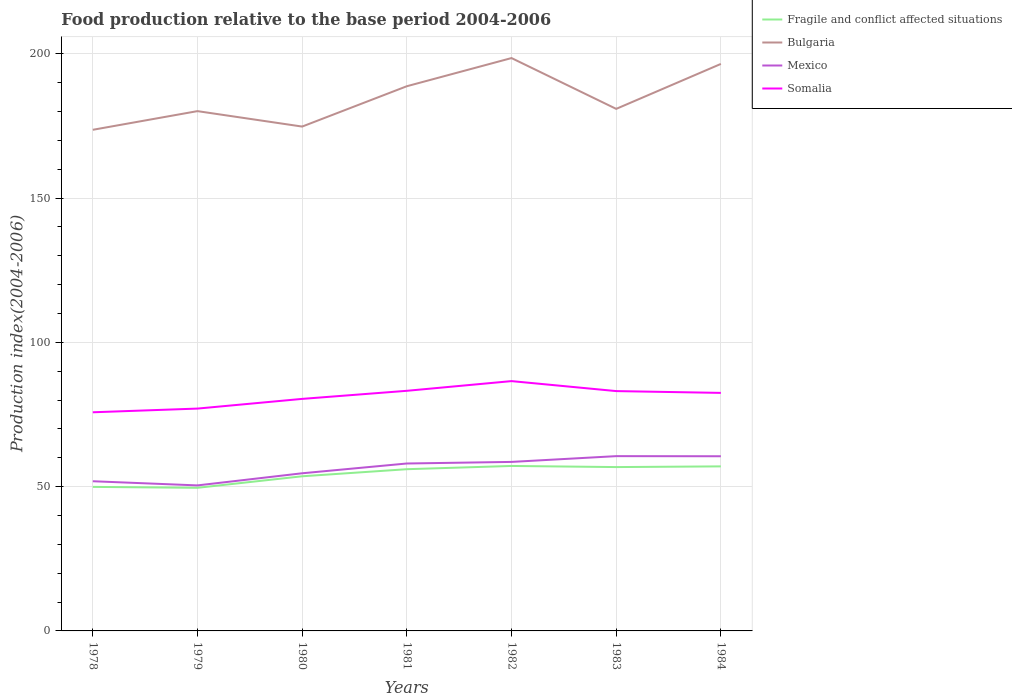Is the number of lines equal to the number of legend labels?
Keep it short and to the point. Yes. Across all years, what is the maximum food production index in Mexico?
Keep it short and to the point. 50.43. In which year was the food production index in Somalia maximum?
Your answer should be very brief. 1978. What is the total food production index in Bulgaria in the graph?
Provide a short and direct response. -15.1. What is the difference between the highest and the second highest food production index in Somalia?
Offer a very short reply. 10.8. Is the food production index in Mexico strictly greater than the food production index in Fragile and conflict affected situations over the years?
Offer a very short reply. No. How many lines are there?
Your response must be concise. 4. How many years are there in the graph?
Provide a short and direct response. 7. What is the difference between two consecutive major ticks on the Y-axis?
Your response must be concise. 50. Are the values on the major ticks of Y-axis written in scientific E-notation?
Your answer should be compact. No. Does the graph contain grids?
Provide a short and direct response. Yes. Where does the legend appear in the graph?
Make the answer very short. Top right. How are the legend labels stacked?
Offer a terse response. Vertical. What is the title of the graph?
Your response must be concise. Food production relative to the base period 2004-2006. Does "Middle East & North Africa (developing only)" appear as one of the legend labels in the graph?
Your answer should be very brief. No. What is the label or title of the Y-axis?
Keep it short and to the point. Production index(2004-2006). What is the Production index(2004-2006) in Fragile and conflict affected situations in 1978?
Your answer should be compact. 49.91. What is the Production index(2004-2006) of Bulgaria in 1978?
Offer a very short reply. 173.66. What is the Production index(2004-2006) of Mexico in 1978?
Your answer should be compact. 51.87. What is the Production index(2004-2006) of Somalia in 1978?
Keep it short and to the point. 75.77. What is the Production index(2004-2006) of Fragile and conflict affected situations in 1979?
Offer a very short reply. 49.59. What is the Production index(2004-2006) in Bulgaria in 1979?
Your response must be concise. 180.13. What is the Production index(2004-2006) in Mexico in 1979?
Offer a terse response. 50.43. What is the Production index(2004-2006) in Somalia in 1979?
Ensure brevity in your answer.  77.05. What is the Production index(2004-2006) of Fragile and conflict affected situations in 1980?
Offer a very short reply. 53.59. What is the Production index(2004-2006) in Bulgaria in 1980?
Offer a terse response. 174.78. What is the Production index(2004-2006) of Mexico in 1980?
Provide a short and direct response. 54.63. What is the Production index(2004-2006) of Somalia in 1980?
Make the answer very short. 80.41. What is the Production index(2004-2006) of Fragile and conflict affected situations in 1981?
Make the answer very short. 56.04. What is the Production index(2004-2006) of Bulgaria in 1981?
Provide a short and direct response. 188.76. What is the Production index(2004-2006) of Mexico in 1981?
Provide a short and direct response. 58.02. What is the Production index(2004-2006) of Somalia in 1981?
Offer a terse response. 83.21. What is the Production index(2004-2006) in Fragile and conflict affected situations in 1982?
Give a very brief answer. 57.17. What is the Production index(2004-2006) in Bulgaria in 1982?
Your response must be concise. 198.52. What is the Production index(2004-2006) of Mexico in 1982?
Give a very brief answer. 58.57. What is the Production index(2004-2006) in Somalia in 1982?
Offer a very short reply. 86.57. What is the Production index(2004-2006) in Fragile and conflict affected situations in 1983?
Provide a succinct answer. 56.78. What is the Production index(2004-2006) of Bulgaria in 1983?
Make the answer very short. 180.91. What is the Production index(2004-2006) of Mexico in 1983?
Offer a terse response. 60.57. What is the Production index(2004-2006) of Somalia in 1983?
Your response must be concise. 83.11. What is the Production index(2004-2006) of Fragile and conflict affected situations in 1984?
Keep it short and to the point. 57.02. What is the Production index(2004-2006) in Bulgaria in 1984?
Your response must be concise. 196.49. What is the Production index(2004-2006) of Mexico in 1984?
Offer a terse response. 60.53. What is the Production index(2004-2006) in Somalia in 1984?
Your answer should be compact. 82.49. Across all years, what is the maximum Production index(2004-2006) of Fragile and conflict affected situations?
Your response must be concise. 57.17. Across all years, what is the maximum Production index(2004-2006) in Bulgaria?
Your answer should be compact. 198.52. Across all years, what is the maximum Production index(2004-2006) in Mexico?
Your answer should be very brief. 60.57. Across all years, what is the maximum Production index(2004-2006) of Somalia?
Ensure brevity in your answer.  86.57. Across all years, what is the minimum Production index(2004-2006) of Fragile and conflict affected situations?
Keep it short and to the point. 49.59. Across all years, what is the minimum Production index(2004-2006) in Bulgaria?
Provide a succinct answer. 173.66. Across all years, what is the minimum Production index(2004-2006) in Mexico?
Offer a very short reply. 50.43. Across all years, what is the minimum Production index(2004-2006) in Somalia?
Keep it short and to the point. 75.77. What is the total Production index(2004-2006) in Fragile and conflict affected situations in the graph?
Your answer should be compact. 380.11. What is the total Production index(2004-2006) of Bulgaria in the graph?
Provide a short and direct response. 1293.25. What is the total Production index(2004-2006) in Mexico in the graph?
Give a very brief answer. 394.62. What is the total Production index(2004-2006) in Somalia in the graph?
Give a very brief answer. 568.61. What is the difference between the Production index(2004-2006) in Fragile and conflict affected situations in 1978 and that in 1979?
Ensure brevity in your answer.  0.32. What is the difference between the Production index(2004-2006) of Bulgaria in 1978 and that in 1979?
Your answer should be compact. -6.47. What is the difference between the Production index(2004-2006) of Mexico in 1978 and that in 1979?
Ensure brevity in your answer.  1.44. What is the difference between the Production index(2004-2006) in Somalia in 1978 and that in 1979?
Offer a very short reply. -1.28. What is the difference between the Production index(2004-2006) in Fragile and conflict affected situations in 1978 and that in 1980?
Your answer should be compact. -3.68. What is the difference between the Production index(2004-2006) in Bulgaria in 1978 and that in 1980?
Ensure brevity in your answer.  -1.12. What is the difference between the Production index(2004-2006) in Mexico in 1978 and that in 1980?
Offer a very short reply. -2.76. What is the difference between the Production index(2004-2006) in Somalia in 1978 and that in 1980?
Provide a succinct answer. -4.64. What is the difference between the Production index(2004-2006) of Fragile and conflict affected situations in 1978 and that in 1981?
Give a very brief answer. -6.13. What is the difference between the Production index(2004-2006) of Bulgaria in 1978 and that in 1981?
Your response must be concise. -15.1. What is the difference between the Production index(2004-2006) in Mexico in 1978 and that in 1981?
Ensure brevity in your answer.  -6.15. What is the difference between the Production index(2004-2006) in Somalia in 1978 and that in 1981?
Provide a short and direct response. -7.44. What is the difference between the Production index(2004-2006) of Fragile and conflict affected situations in 1978 and that in 1982?
Provide a short and direct response. -7.26. What is the difference between the Production index(2004-2006) of Bulgaria in 1978 and that in 1982?
Offer a very short reply. -24.86. What is the difference between the Production index(2004-2006) of Fragile and conflict affected situations in 1978 and that in 1983?
Your answer should be very brief. -6.87. What is the difference between the Production index(2004-2006) of Bulgaria in 1978 and that in 1983?
Your response must be concise. -7.25. What is the difference between the Production index(2004-2006) of Mexico in 1978 and that in 1983?
Ensure brevity in your answer.  -8.7. What is the difference between the Production index(2004-2006) of Somalia in 1978 and that in 1983?
Provide a succinct answer. -7.34. What is the difference between the Production index(2004-2006) of Fragile and conflict affected situations in 1978 and that in 1984?
Make the answer very short. -7.11. What is the difference between the Production index(2004-2006) of Bulgaria in 1978 and that in 1984?
Offer a terse response. -22.83. What is the difference between the Production index(2004-2006) of Mexico in 1978 and that in 1984?
Offer a very short reply. -8.66. What is the difference between the Production index(2004-2006) in Somalia in 1978 and that in 1984?
Keep it short and to the point. -6.72. What is the difference between the Production index(2004-2006) of Fragile and conflict affected situations in 1979 and that in 1980?
Provide a short and direct response. -3.99. What is the difference between the Production index(2004-2006) in Bulgaria in 1979 and that in 1980?
Your answer should be very brief. 5.35. What is the difference between the Production index(2004-2006) in Somalia in 1979 and that in 1980?
Your answer should be very brief. -3.36. What is the difference between the Production index(2004-2006) in Fragile and conflict affected situations in 1979 and that in 1981?
Make the answer very short. -6.45. What is the difference between the Production index(2004-2006) in Bulgaria in 1979 and that in 1981?
Your answer should be compact. -8.63. What is the difference between the Production index(2004-2006) of Mexico in 1979 and that in 1981?
Provide a succinct answer. -7.59. What is the difference between the Production index(2004-2006) of Somalia in 1979 and that in 1981?
Make the answer very short. -6.16. What is the difference between the Production index(2004-2006) in Fragile and conflict affected situations in 1979 and that in 1982?
Your answer should be very brief. -7.58. What is the difference between the Production index(2004-2006) in Bulgaria in 1979 and that in 1982?
Offer a terse response. -18.39. What is the difference between the Production index(2004-2006) of Mexico in 1979 and that in 1982?
Keep it short and to the point. -8.14. What is the difference between the Production index(2004-2006) of Somalia in 1979 and that in 1982?
Provide a succinct answer. -9.52. What is the difference between the Production index(2004-2006) in Fragile and conflict affected situations in 1979 and that in 1983?
Your answer should be compact. -7.18. What is the difference between the Production index(2004-2006) of Bulgaria in 1979 and that in 1983?
Your answer should be compact. -0.78. What is the difference between the Production index(2004-2006) of Mexico in 1979 and that in 1983?
Keep it short and to the point. -10.14. What is the difference between the Production index(2004-2006) of Somalia in 1979 and that in 1983?
Your answer should be compact. -6.06. What is the difference between the Production index(2004-2006) in Fragile and conflict affected situations in 1979 and that in 1984?
Your response must be concise. -7.43. What is the difference between the Production index(2004-2006) in Bulgaria in 1979 and that in 1984?
Your answer should be very brief. -16.36. What is the difference between the Production index(2004-2006) of Mexico in 1979 and that in 1984?
Ensure brevity in your answer.  -10.1. What is the difference between the Production index(2004-2006) in Somalia in 1979 and that in 1984?
Your response must be concise. -5.44. What is the difference between the Production index(2004-2006) of Fragile and conflict affected situations in 1980 and that in 1981?
Offer a very short reply. -2.45. What is the difference between the Production index(2004-2006) in Bulgaria in 1980 and that in 1981?
Make the answer very short. -13.98. What is the difference between the Production index(2004-2006) of Mexico in 1980 and that in 1981?
Offer a very short reply. -3.39. What is the difference between the Production index(2004-2006) in Somalia in 1980 and that in 1981?
Offer a very short reply. -2.8. What is the difference between the Production index(2004-2006) of Fragile and conflict affected situations in 1980 and that in 1982?
Your answer should be very brief. -3.58. What is the difference between the Production index(2004-2006) of Bulgaria in 1980 and that in 1982?
Offer a very short reply. -23.74. What is the difference between the Production index(2004-2006) in Mexico in 1980 and that in 1982?
Ensure brevity in your answer.  -3.94. What is the difference between the Production index(2004-2006) of Somalia in 1980 and that in 1982?
Offer a terse response. -6.16. What is the difference between the Production index(2004-2006) of Fragile and conflict affected situations in 1980 and that in 1983?
Your answer should be very brief. -3.19. What is the difference between the Production index(2004-2006) of Bulgaria in 1980 and that in 1983?
Your response must be concise. -6.13. What is the difference between the Production index(2004-2006) in Mexico in 1980 and that in 1983?
Your answer should be very brief. -5.94. What is the difference between the Production index(2004-2006) of Fragile and conflict affected situations in 1980 and that in 1984?
Offer a terse response. -3.43. What is the difference between the Production index(2004-2006) of Bulgaria in 1980 and that in 1984?
Make the answer very short. -21.71. What is the difference between the Production index(2004-2006) in Somalia in 1980 and that in 1984?
Keep it short and to the point. -2.08. What is the difference between the Production index(2004-2006) of Fragile and conflict affected situations in 1981 and that in 1982?
Your answer should be compact. -1.13. What is the difference between the Production index(2004-2006) in Bulgaria in 1981 and that in 1982?
Provide a short and direct response. -9.76. What is the difference between the Production index(2004-2006) in Mexico in 1981 and that in 1982?
Ensure brevity in your answer.  -0.55. What is the difference between the Production index(2004-2006) in Somalia in 1981 and that in 1982?
Ensure brevity in your answer.  -3.36. What is the difference between the Production index(2004-2006) of Fragile and conflict affected situations in 1981 and that in 1983?
Keep it short and to the point. -0.74. What is the difference between the Production index(2004-2006) in Bulgaria in 1981 and that in 1983?
Provide a succinct answer. 7.85. What is the difference between the Production index(2004-2006) in Mexico in 1981 and that in 1983?
Provide a short and direct response. -2.55. What is the difference between the Production index(2004-2006) in Fragile and conflict affected situations in 1981 and that in 1984?
Offer a very short reply. -0.98. What is the difference between the Production index(2004-2006) of Bulgaria in 1981 and that in 1984?
Your answer should be compact. -7.73. What is the difference between the Production index(2004-2006) in Mexico in 1981 and that in 1984?
Your response must be concise. -2.51. What is the difference between the Production index(2004-2006) in Somalia in 1981 and that in 1984?
Provide a succinct answer. 0.72. What is the difference between the Production index(2004-2006) in Fragile and conflict affected situations in 1982 and that in 1983?
Make the answer very short. 0.39. What is the difference between the Production index(2004-2006) of Bulgaria in 1982 and that in 1983?
Your response must be concise. 17.61. What is the difference between the Production index(2004-2006) of Mexico in 1982 and that in 1983?
Give a very brief answer. -2. What is the difference between the Production index(2004-2006) in Somalia in 1982 and that in 1983?
Provide a short and direct response. 3.46. What is the difference between the Production index(2004-2006) in Fragile and conflict affected situations in 1982 and that in 1984?
Provide a short and direct response. 0.15. What is the difference between the Production index(2004-2006) of Bulgaria in 1982 and that in 1984?
Your answer should be very brief. 2.03. What is the difference between the Production index(2004-2006) in Mexico in 1982 and that in 1984?
Give a very brief answer. -1.96. What is the difference between the Production index(2004-2006) in Somalia in 1982 and that in 1984?
Ensure brevity in your answer.  4.08. What is the difference between the Production index(2004-2006) of Fragile and conflict affected situations in 1983 and that in 1984?
Provide a succinct answer. -0.24. What is the difference between the Production index(2004-2006) in Bulgaria in 1983 and that in 1984?
Offer a terse response. -15.58. What is the difference between the Production index(2004-2006) of Somalia in 1983 and that in 1984?
Your response must be concise. 0.62. What is the difference between the Production index(2004-2006) in Fragile and conflict affected situations in 1978 and the Production index(2004-2006) in Bulgaria in 1979?
Your answer should be compact. -130.22. What is the difference between the Production index(2004-2006) in Fragile and conflict affected situations in 1978 and the Production index(2004-2006) in Mexico in 1979?
Provide a short and direct response. -0.52. What is the difference between the Production index(2004-2006) in Fragile and conflict affected situations in 1978 and the Production index(2004-2006) in Somalia in 1979?
Ensure brevity in your answer.  -27.14. What is the difference between the Production index(2004-2006) in Bulgaria in 1978 and the Production index(2004-2006) in Mexico in 1979?
Ensure brevity in your answer.  123.23. What is the difference between the Production index(2004-2006) of Bulgaria in 1978 and the Production index(2004-2006) of Somalia in 1979?
Make the answer very short. 96.61. What is the difference between the Production index(2004-2006) of Mexico in 1978 and the Production index(2004-2006) of Somalia in 1979?
Provide a succinct answer. -25.18. What is the difference between the Production index(2004-2006) in Fragile and conflict affected situations in 1978 and the Production index(2004-2006) in Bulgaria in 1980?
Ensure brevity in your answer.  -124.87. What is the difference between the Production index(2004-2006) of Fragile and conflict affected situations in 1978 and the Production index(2004-2006) of Mexico in 1980?
Ensure brevity in your answer.  -4.72. What is the difference between the Production index(2004-2006) in Fragile and conflict affected situations in 1978 and the Production index(2004-2006) in Somalia in 1980?
Ensure brevity in your answer.  -30.5. What is the difference between the Production index(2004-2006) in Bulgaria in 1978 and the Production index(2004-2006) in Mexico in 1980?
Give a very brief answer. 119.03. What is the difference between the Production index(2004-2006) in Bulgaria in 1978 and the Production index(2004-2006) in Somalia in 1980?
Provide a short and direct response. 93.25. What is the difference between the Production index(2004-2006) of Mexico in 1978 and the Production index(2004-2006) of Somalia in 1980?
Your response must be concise. -28.54. What is the difference between the Production index(2004-2006) of Fragile and conflict affected situations in 1978 and the Production index(2004-2006) of Bulgaria in 1981?
Your answer should be very brief. -138.85. What is the difference between the Production index(2004-2006) of Fragile and conflict affected situations in 1978 and the Production index(2004-2006) of Mexico in 1981?
Offer a terse response. -8.11. What is the difference between the Production index(2004-2006) in Fragile and conflict affected situations in 1978 and the Production index(2004-2006) in Somalia in 1981?
Keep it short and to the point. -33.3. What is the difference between the Production index(2004-2006) in Bulgaria in 1978 and the Production index(2004-2006) in Mexico in 1981?
Provide a succinct answer. 115.64. What is the difference between the Production index(2004-2006) of Bulgaria in 1978 and the Production index(2004-2006) of Somalia in 1981?
Your answer should be compact. 90.45. What is the difference between the Production index(2004-2006) in Mexico in 1978 and the Production index(2004-2006) in Somalia in 1981?
Your response must be concise. -31.34. What is the difference between the Production index(2004-2006) of Fragile and conflict affected situations in 1978 and the Production index(2004-2006) of Bulgaria in 1982?
Provide a short and direct response. -148.61. What is the difference between the Production index(2004-2006) of Fragile and conflict affected situations in 1978 and the Production index(2004-2006) of Mexico in 1982?
Provide a short and direct response. -8.66. What is the difference between the Production index(2004-2006) of Fragile and conflict affected situations in 1978 and the Production index(2004-2006) of Somalia in 1982?
Your answer should be very brief. -36.66. What is the difference between the Production index(2004-2006) of Bulgaria in 1978 and the Production index(2004-2006) of Mexico in 1982?
Keep it short and to the point. 115.09. What is the difference between the Production index(2004-2006) of Bulgaria in 1978 and the Production index(2004-2006) of Somalia in 1982?
Provide a short and direct response. 87.09. What is the difference between the Production index(2004-2006) in Mexico in 1978 and the Production index(2004-2006) in Somalia in 1982?
Offer a terse response. -34.7. What is the difference between the Production index(2004-2006) in Fragile and conflict affected situations in 1978 and the Production index(2004-2006) in Bulgaria in 1983?
Give a very brief answer. -131. What is the difference between the Production index(2004-2006) in Fragile and conflict affected situations in 1978 and the Production index(2004-2006) in Mexico in 1983?
Your answer should be compact. -10.66. What is the difference between the Production index(2004-2006) in Fragile and conflict affected situations in 1978 and the Production index(2004-2006) in Somalia in 1983?
Provide a succinct answer. -33.2. What is the difference between the Production index(2004-2006) of Bulgaria in 1978 and the Production index(2004-2006) of Mexico in 1983?
Ensure brevity in your answer.  113.09. What is the difference between the Production index(2004-2006) of Bulgaria in 1978 and the Production index(2004-2006) of Somalia in 1983?
Offer a terse response. 90.55. What is the difference between the Production index(2004-2006) of Mexico in 1978 and the Production index(2004-2006) of Somalia in 1983?
Keep it short and to the point. -31.24. What is the difference between the Production index(2004-2006) in Fragile and conflict affected situations in 1978 and the Production index(2004-2006) in Bulgaria in 1984?
Offer a very short reply. -146.58. What is the difference between the Production index(2004-2006) of Fragile and conflict affected situations in 1978 and the Production index(2004-2006) of Mexico in 1984?
Your answer should be compact. -10.62. What is the difference between the Production index(2004-2006) in Fragile and conflict affected situations in 1978 and the Production index(2004-2006) in Somalia in 1984?
Your answer should be very brief. -32.58. What is the difference between the Production index(2004-2006) in Bulgaria in 1978 and the Production index(2004-2006) in Mexico in 1984?
Ensure brevity in your answer.  113.13. What is the difference between the Production index(2004-2006) in Bulgaria in 1978 and the Production index(2004-2006) in Somalia in 1984?
Keep it short and to the point. 91.17. What is the difference between the Production index(2004-2006) of Mexico in 1978 and the Production index(2004-2006) of Somalia in 1984?
Make the answer very short. -30.62. What is the difference between the Production index(2004-2006) in Fragile and conflict affected situations in 1979 and the Production index(2004-2006) in Bulgaria in 1980?
Give a very brief answer. -125.19. What is the difference between the Production index(2004-2006) of Fragile and conflict affected situations in 1979 and the Production index(2004-2006) of Mexico in 1980?
Your answer should be compact. -5.04. What is the difference between the Production index(2004-2006) in Fragile and conflict affected situations in 1979 and the Production index(2004-2006) in Somalia in 1980?
Offer a terse response. -30.82. What is the difference between the Production index(2004-2006) of Bulgaria in 1979 and the Production index(2004-2006) of Mexico in 1980?
Your answer should be compact. 125.5. What is the difference between the Production index(2004-2006) of Bulgaria in 1979 and the Production index(2004-2006) of Somalia in 1980?
Your answer should be compact. 99.72. What is the difference between the Production index(2004-2006) of Mexico in 1979 and the Production index(2004-2006) of Somalia in 1980?
Offer a terse response. -29.98. What is the difference between the Production index(2004-2006) in Fragile and conflict affected situations in 1979 and the Production index(2004-2006) in Bulgaria in 1981?
Provide a succinct answer. -139.17. What is the difference between the Production index(2004-2006) in Fragile and conflict affected situations in 1979 and the Production index(2004-2006) in Mexico in 1981?
Your answer should be very brief. -8.43. What is the difference between the Production index(2004-2006) in Fragile and conflict affected situations in 1979 and the Production index(2004-2006) in Somalia in 1981?
Keep it short and to the point. -33.62. What is the difference between the Production index(2004-2006) in Bulgaria in 1979 and the Production index(2004-2006) in Mexico in 1981?
Make the answer very short. 122.11. What is the difference between the Production index(2004-2006) in Bulgaria in 1979 and the Production index(2004-2006) in Somalia in 1981?
Ensure brevity in your answer.  96.92. What is the difference between the Production index(2004-2006) in Mexico in 1979 and the Production index(2004-2006) in Somalia in 1981?
Your answer should be compact. -32.78. What is the difference between the Production index(2004-2006) of Fragile and conflict affected situations in 1979 and the Production index(2004-2006) of Bulgaria in 1982?
Your answer should be very brief. -148.93. What is the difference between the Production index(2004-2006) in Fragile and conflict affected situations in 1979 and the Production index(2004-2006) in Mexico in 1982?
Your answer should be very brief. -8.98. What is the difference between the Production index(2004-2006) in Fragile and conflict affected situations in 1979 and the Production index(2004-2006) in Somalia in 1982?
Provide a short and direct response. -36.98. What is the difference between the Production index(2004-2006) of Bulgaria in 1979 and the Production index(2004-2006) of Mexico in 1982?
Provide a short and direct response. 121.56. What is the difference between the Production index(2004-2006) in Bulgaria in 1979 and the Production index(2004-2006) in Somalia in 1982?
Provide a succinct answer. 93.56. What is the difference between the Production index(2004-2006) of Mexico in 1979 and the Production index(2004-2006) of Somalia in 1982?
Your answer should be compact. -36.14. What is the difference between the Production index(2004-2006) of Fragile and conflict affected situations in 1979 and the Production index(2004-2006) of Bulgaria in 1983?
Offer a very short reply. -131.32. What is the difference between the Production index(2004-2006) of Fragile and conflict affected situations in 1979 and the Production index(2004-2006) of Mexico in 1983?
Your answer should be compact. -10.98. What is the difference between the Production index(2004-2006) in Fragile and conflict affected situations in 1979 and the Production index(2004-2006) in Somalia in 1983?
Your answer should be compact. -33.52. What is the difference between the Production index(2004-2006) in Bulgaria in 1979 and the Production index(2004-2006) in Mexico in 1983?
Keep it short and to the point. 119.56. What is the difference between the Production index(2004-2006) in Bulgaria in 1979 and the Production index(2004-2006) in Somalia in 1983?
Make the answer very short. 97.02. What is the difference between the Production index(2004-2006) in Mexico in 1979 and the Production index(2004-2006) in Somalia in 1983?
Your answer should be very brief. -32.68. What is the difference between the Production index(2004-2006) of Fragile and conflict affected situations in 1979 and the Production index(2004-2006) of Bulgaria in 1984?
Your answer should be very brief. -146.9. What is the difference between the Production index(2004-2006) of Fragile and conflict affected situations in 1979 and the Production index(2004-2006) of Mexico in 1984?
Give a very brief answer. -10.94. What is the difference between the Production index(2004-2006) in Fragile and conflict affected situations in 1979 and the Production index(2004-2006) in Somalia in 1984?
Your response must be concise. -32.9. What is the difference between the Production index(2004-2006) of Bulgaria in 1979 and the Production index(2004-2006) of Mexico in 1984?
Your answer should be compact. 119.6. What is the difference between the Production index(2004-2006) in Bulgaria in 1979 and the Production index(2004-2006) in Somalia in 1984?
Your answer should be compact. 97.64. What is the difference between the Production index(2004-2006) of Mexico in 1979 and the Production index(2004-2006) of Somalia in 1984?
Provide a succinct answer. -32.06. What is the difference between the Production index(2004-2006) in Fragile and conflict affected situations in 1980 and the Production index(2004-2006) in Bulgaria in 1981?
Your answer should be very brief. -135.17. What is the difference between the Production index(2004-2006) of Fragile and conflict affected situations in 1980 and the Production index(2004-2006) of Mexico in 1981?
Provide a short and direct response. -4.43. What is the difference between the Production index(2004-2006) of Fragile and conflict affected situations in 1980 and the Production index(2004-2006) of Somalia in 1981?
Your answer should be compact. -29.62. What is the difference between the Production index(2004-2006) in Bulgaria in 1980 and the Production index(2004-2006) in Mexico in 1981?
Make the answer very short. 116.76. What is the difference between the Production index(2004-2006) of Bulgaria in 1980 and the Production index(2004-2006) of Somalia in 1981?
Ensure brevity in your answer.  91.57. What is the difference between the Production index(2004-2006) in Mexico in 1980 and the Production index(2004-2006) in Somalia in 1981?
Make the answer very short. -28.58. What is the difference between the Production index(2004-2006) of Fragile and conflict affected situations in 1980 and the Production index(2004-2006) of Bulgaria in 1982?
Provide a succinct answer. -144.93. What is the difference between the Production index(2004-2006) of Fragile and conflict affected situations in 1980 and the Production index(2004-2006) of Mexico in 1982?
Your response must be concise. -4.98. What is the difference between the Production index(2004-2006) of Fragile and conflict affected situations in 1980 and the Production index(2004-2006) of Somalia in 1982?
Give a very brief answer. -32.98. What is the difference between the Production index(2004-2006) in Bulgaria in 1980 and the Production index(2004-2006) in Mexico in 1982?
Your answer should be compact. 116.21. What is the difference between the Production index(2004-2006) in Bulgaria in 1980 and the Production index(2004-2006) in Somalia in 1982?
Provide a succinct answer. 88.21. What is the difference between the Production index(2004-2006) in Mexico in 1980 and the Production index(2004-2006) in Somalia in 1982?
Your response must be concise. -31.94. What is the difference between the Production index(2004-2006) in Fragile and conflict affected situations in 1980 and the Production index(2004-2006) in Bulgaria in 1983?
Provide a succinct answer. -127.32. What is the difference between the Production index(2004-2006) of Fragile and conflict affected situations in 1980 and the Production index(2004-2006) of Mexico in 1983?
Offer a very short reply. -6.98. What is the difference between the Production index(2004-2006) in Fragile and conflict affected situations in 1980 and the Production index(2004-2006) in Somalia in 1983?
Your answer should be compact. -29.52. What is the difference between the Production index(2004-2006) in Bulgaria in 1980 and the Production index(2004-2006) in Mexico in 1983?
Your answer should be compact. 114.21. What is the difference between the Production index(2004-2006) of Bulgaria in 1980 and the Production index(2004-2006) of Somalia in 1983?
Your answer should be compact. 91.67. What is the difference between the Production index(2004-2006) of Mexico in 1980 and the Production index(2004-2006) of Somalia in 1983?
Make the answer very short. -28.48. What is the difference between the Production index(2004-2006) of Fragile and conflict affected situations in 1980 and the Production index(2004-2006) of Bulgaria in 1984?
Provide a succinct answer. -142.9. What is the difference between the Production index(2004-2006) of Fragile and conflict affected situations in 1980 and the Production index(2004-2006) of Mexico in 1984?
Offer a very short reply. -6.94. What is the difference between the Production index(2004-2006) in Fragile and conflict affected situations in 1980 and the Production index(2004-2006) in Somalia in 1984?
Offer a very short reply. -28.9. What is the difference between the Production index(2004-2006) in Bulgaria in 1980 and the Production index(2004-2006) in Mexico in 1984?
Offer a very short reply. 114.25. What is the difference between the Production index(2004-2006) of Bulgaria in 1980 and the Production index(2004-2006) of Somalia in 1984?
Keep it short and to the point. 92.29. What is the difference between the Production index(2004-2006) in Mexico in 1980 and the Production index(2004-2006) in Somalia in 1984?
Provide a short and direct response. -27.86. What is the difference between the Production index(2004-2006) in Fragile and conflict affected situations in 1981 and the Production index(2004-2006) in Bulgaria in 1982?
Give a very brief answer. -142.48. What is the difference between the Production index(2004-2006) in Fragile and conflict affected situations in 1981 and the Production index(2004-2006) in Mexico in 1982?
Provide a succinct answer. -2.53. What is the difference between the Production index(2004-2006) of Fragile and conflict affected situations in 1981 and the Production index(2004-2006) of Somalia in 1982?
Your answer should be compact. -30.53. What is the difference between the Production index(2004-2006) in Bulgaria in 1981 and the Production index(2004-2006) in Mexico in 1982?
Make the answer very short. 130.19. What is the difference between the Production index(2004-2006) of Bulgaria in 1981 and the Production index(2004-2006) of Somalia in 1982?
Your answer should be very brief. 102.19. What is the difference between the Production index(2004-2006) in Mexico in 1981 and the Production index(2004-2006) in Somalia in 1982?
Ensure brevity in your answer.  -28.55. What is the difference between the Production index(2004-2006) of Fragile and conflict affected situations in 1981 and the Production index(2004-2006) of Bulgaria in 1983?
Give a very brief answer. -124.87. What is the difference between the Production index(2004-2006) in Fragile and conflict affected situations in 1981 and the Production index(2004-2006) in Mexico in 1983?
Provide a succinct answer. -4.53. What is the difference between the Production index(2004-2006) of Fragile and conflict affected situations in 1981 and the Production index(2004-2006) of Somalia in 1983?
Keep it short and to the point. -27.07. What is the difference between the Production index(2004-2006) of Bulgaria in 1981 and the Production index(2004-2006) of Mexico in 1983?
Offer a very short reply. 128.19. What is the difference between the Production index(2004-2006) in Bulgaria in 1981 and the Production index(2004-2006) in Somalia in 1983?
Keep it short and to the point. 105.65. What is the difference between the Production index(2004-2006) in Mexico in 1981 and the Production index(2004-2006) in Somalia in 1983?
Ensure brevity in your answer.  -25.09. What is the difference between the Production index(2004-2006) of Fragile and conflict affected situations in 1981 and the Production index(2004-2006) of Bulgaria in 1984?
Give a very brief answer. -140.45. What is the difference between the Production index(2004-2006) of Fragile and conflict affected situations in 1981 and the Production index(2004-2006) of Mexico in 1984?
Your answer should be compact. -4.49. What is the difference between the Production index(2004-2006) in Fragile and conflict affected situations in 1981 and the Production index(2004-2006) in Somalia in 1984?
Keep it short and to the point. -26.45. What is the difference between the Production index(2004-2006) of Bulgaria in 1981 and the Production index(2004-2006) of Mexico in 1984?
Offer a terse response. 128.23. What is the difference between the Production index(2004-2006) in Bulgaria in 1981 and the Production index(2004-2006) in Somalia in 1984?
Offer a very short reply. 106.27. What is the difference between the Production index(2004-2006) in Mexico in 1981 and the Production index(2004-2006) in Somalia in 1984?
Make the answer very short. -24.47. What is the difference between the Production index(2004-2006) in Fragile and conflict affected situations in 1982 and the Production index(2004-2006) in Bulgaria in 1983?
Make the answer very short. -123.74. What is the difference between the Production index(2004-2006) of Fragile and conflict affected situations in 1982 and the Production index(2004-2006) of Mexico in 1983?
Keep it short and to the point. -3.4. What is the difference between the Production index(2004-2006) of Fragile and conflict affected situations in 1982 and the Production index(2004-2006) of Somalia in 1983?
Your response must be concise. -25.94. What is the difference between the Production index(2004-2006) in Bulgaria in 1982 and the Production index(2004-2006) in Mexico in 1983?
Offer a very short reply. 137.95. What is the difference between the Production index(2004-2006) of Bulgaria in 1982 and the Production index(2004-2006) of Somalia in 1983?
Give a very brief answer. 115.41. What is the difference between the Production index(2004-2006) of Mexico in 1982 and the Production index(2004-2006) of Somalia in 1983?
Ensure brevity in your answer.  -24.54. What is the difference between the Production index(2004-2006) in Fragile and conflict affected situations in 1982 and the Production index(2004-2006) in Bulgaria in 1984?
Your answer should be compact. -139.32. What is the difference between the Production index(2004-2006) in Fragile and conflict affected situations in 1982 and the Production index(2004-2006) in Mexico in 1984?
Your answer should be very brief. -3.36. What is the difference between the Production index(2004-2006) in Fragile and conflict affected situations in 1982 and the Production index(2004-2006) in Somalia in 1984?
Make the answer very short. -25.32. What is the difference between the Production index(2004-2006) in Bulgaria in 1982 and the Production index(2004-2006) in Mexico in 1984?
Your answer should be very brief. 137.99. What is the difference between the Production index(2004-2006) of Bulgaria in 1982 and the Production index(2004-2006) of Somalia in 1984?
Keep it short and to the point. 116.03. What is the difference between the Production index(2004-2006) of Mexico in 1982 and the Production index(2004-2006) of Somalia in 1984?
Make the answer very short. -23.92. What is the difference between the Production index(2004-2006) of Fragile and conflict affected situations in 1983 and the Production index(2004-2006) of Bulgaria in 1984?
Your answer should be compact. -139.71. What is the difference between the Production index(2004-2006) in Fragile and conflict affected situations in 1983 and the Production index(2004-2006) in Mexico in 1984?
Make the answer very short. -3.75. What is the difference between the Production index(2004-2006) in Fragile and conflict affected situations in 1983 and the Production index(2004-2006) in Somalia in 1984?
Your answer should be very brief. -25.71. What is the difference between the Production index(2004-2006) of Bulgaria in 1983 and the Production index(2004-2006) of Mexico in 1984?
Provide a short and direct response. 120.38. What is the difference between the Production index(2004-2006) in Bulgaria in 1983 and the Production index(2004-2006) in Somalia in 1984?
Keep it short and to the point. 98.42. What is the difference between the Production index(2004-2006) in Mexico in 1983 and the Production index(2004-2006) in Somalia in 1984?
Offer a terse response. -21.92. What is the average Production index(2004-2006) in Fragile and conflict affected situations per year?
Make the answer very short. 54.3. What is the average Production index(2004-2006) in Bulgaria per year?
Your response must be concise. 184.75. What is the average Production index(2004-2006) of Mexico per year?
Give a very brief answer. 56.37. What is the average Production index(2004-2006) of Somalia per year?
Offer a very short reply. 81.23. In the year 1978, what is the difference between the Production index(2004-2006) of Fragile and conflict affected situations and Production index(2004-2006) of Bulgaria?
Ensure brevity in your answer.  -123.75. In the year 1978, what is the difference between the Production index(2004-2006) of Fragile and conflict affected situations and Production index(2004-2006) of Mexico?
Keep it short and to the point. -1.96. In the year 1978, what is the difference between the Production index(2004-2006) in Fragile and conflict affected situations and Production index(2004-2006) in Somalia?
Your response must be concise. -25.86. In the year 1978, what is the difference between the Production index(2004-2006) of Bulgaria and Production index(2004-2006) of Mexico?
Ensure brevity in your answer.  121.79. In the year 1978, what is the difference between the Production index(2004-2006) of Bulgaria and Production index(2004-2006) of Somalia?
Your answer should be very brief. 97.89. In the year 1978, what is the difference between the Production index(2004-2006) in Mexico and Production index(2004-2006) in Somalia?
Provide a succinct answer. -23.9. In the year 1979, what is the difference between the Production index(2004-2006) in Fragile and conflict affected situations and Production index(2004-2006) in Bulgaria?
Ensure brevity in your answer.  -130.54. In the year 1979, what is the difference between the Production index(2004-2006) in Fragile and conflict affected situations and Production index(2004-2006) in Mexico?
Make the answer very short. -0.84. In the year 1979, what is the difference between the Production index(2004-2006) of Fragile and conflict affected situations and Production index(2004-2006) of Somalia?
Offer a very short reply. -27.46. In the year 1979, what is the difference between the Production index(2004-2006) in Bulgaria and Production index(2004-2006) in Mexico?
Your response must be concise. 129.7. In the year 1979, what is the difference between the Production index(2004-2006) of Bulgaria and Production index(2004-2006) of Somalia?
Your answer should be compact. 103.08. In the year 1979, what is the difference between the Production index(2004-2006) in Mexico and Production index(2004-2006) in Somalia?
Make the answer very short. -26.62. In the year 1980, what is the difference between the Production index(2004-2006) of Fragile and conflict affected situations and Production index(2004-2006) of Bulgaria?
Ensure brevity in your answer.  -121.19. In the year 1980, what is the difference between the Production index(2004-2006) of Fragile and conflict affected situations and Production index(2004-2006) of Mexico?
Offer a very short reply. -1.04. In the year 1980, what is the difference between the Production index(2004-2006) of Fragile and conflict affected situations and Production index(2004-2006) of Somalia?
Your response must be concise. -26.82. In the year 1980, what is the difference between the Production index(2004-2006) of Bulgaria and Production index(2004-2006) of Mexico?
Offer a very short reply. 120.15. In the year 1980, what is the difference between the Production index(2004-2006) of Bulgaria and Production index(2004-2006) of Somalia?
Your response must be concise. 94.37. In the year 1980, what is the difference between the Production index(2004-2006) of Mexico and Production index(2004-2006) of Somalia?
Give a very brief answer. -25.78. In the year 1981, what is the difference between the Production index(2004-2006) of Fragile and conflict affected situations and Production index(2004-2006) of Bulgaria?
Offer a very short reply. -132.72. In the year 1981, what is the difference between the Production index(2004-2006) of Fragile and conflict affected situations and Production index(2004-2006) of Mexico?
Give a very brief answer. -1.98. In the year 1981, what is the difference between the Production index(2004-2006) of Fragile and conflict affected situations and Production index(2004-2006) of Somalia?
Give a very brief answer. -27.17. In the year 1981, what is the difference between the Production index(2004-2006) of Bulgaria and Production index(2004-2006) of Mexico?
Offer a terse response. 130.74. In the year 1981, what is the difference between the Production index(2004-2006) in Bulgaria and Production index(2004-2006) in Somalia?
Offer a terse response. 105.55. In the year 1981, what is the difference between the Production index(2004-2006) in Mexico and Production index(2004-2006) in Somalia?
Provide a short and direct response. -25.19. In the year 1982, what is the difference between the Production index(2004-2006) in Fragile and conflict affected situations and Production index(2004-2006) in Bulgaria?
Offer a terse response. -141.35. In the year 1982, what is the difference between the Production index(2004-2006) of Fragile and conflict affected situations and Production index(2004-2006) of Mexico?
Offer a very short reply. -1.4. In the year 1982, what is the difference between the Production index(2004-2006) in Fragile and conflict affected situations and Production index(2004-2006) in Somalia?
Offer a terse response. -29.4. In the year 1982, what is the difference between the Production index(2004-2006) of Bulgaria and Production index(2004-2006) of Mexico?
Your answer should be very brief. 139.95. In the year 1982, what is the difference between the Production index(2004-2006) in Bulgaria and Production index(2004-2006) in Somalia?
Offer a very short reply. 111.95. In the year 1982, what is the difference between the Production index(2004-2006) of Mexico and Production index(2004-2006) of Somalia?
Provide a short and direct response. -28. In the year 1983, what is the difference between the Production index(2004-2006) in Fragile and conflict affected situations and Production index(2004-2006) in Bulgaria?
Offer a very short reply. -124.13. In the year 1983, what is the difference between the Production index(2004-2006) of Fragile and conflict affected situations and Production index(2004-2006) of Mexico?
Keep it short and to the point. -3.79. In the year 1983, what is the difference between the Production index(2004-2006) of Fragile and conflict affected situations and Production index(2004-2006) of Somalia?
Provide a short and direct response. -26.33. In the year 1983, what is the difference between the Production index(2004-2006) in Bulgaria and Production index(2004-2006) in Mexico?
Offer a very short reply. 120.34. In the year 1983, what is the difference between the Production index(2004-2006) of Bulgaria and Production index(2004-2006) of Somalia?
Provide a short and direct response. 97.8. In the year 1983, what is the difference between the Production index(2004-2006) in Mexico and Production index(2004-2006) in Somalia?
Make the answer very short. -22.54. In the year 1984, what is the difference between the Production index(2004-2006) of Fragile and conflict affected situations and Production index(2004-2006) of Bulgaria?
Your answer should be compact. -139.47. In the year 1984, what is the difference between the Production index(2004-2006) of Fragile and conflict affected situations and Production index(2004-2006) of Mexico?
Provide a succinct answer. -3.51. In the year 1984, what is the difference between the Production index(2004-2006) in Fragile and conflict affected situations and Production index(2004-2006) in Somalia?
Ensure brevity in your answer.  -25.47. In the year 1984, what is the difference between the Production index(2004-2006) in Bulgaria and Production index(2004-2006) in Mexico?
Your answer should be compact. 135.96. In the year 1984, what is the difference between the Production index(2004-2006) of Bulgaria and Production index(2004-2006) of Somalia?
Your answer should be very brief. 114. In the year 1984, what is the difference between the Production index(2004-2006) of Mexico and Production index(2004-2006) of Somalia?
Your response must be concise. -21.96. What is the ratio of the Production index(2004-2006) of Fragile and conflict affected situations in 1978 to that in 1979?
Keep it short and to the point. 1.01. What is the ratio of the Production index(2004-2006) in Bulgaria in 1978 to that in 1979?
Your answer should be compact. 0.96. What is the ratio of the Production index(2004-2006) in Mexico in 1978 to that in 1979?
Offer a terse response. 1.03. What is the ratio of the Production index(2004-2006) in Somalia in 1978 to that in 1979?
Ensure brevity in your answer.  0.98. What is the ratio of the Production index(2004-2006) in Fragile and conflict affected situations in 1978 to that in 1980?
Provide a short and direct response. 0.93. What is the ratio of the Production index(2004-2006) of Mexico in 1978 to that in 1980?
Offer a terse response. 0.95. What is the ratio of the Production index(2004-2006) of Somalia in 1978 to that in 1980?
Give a very brief answer. 0.94. What is the ratio of the Production index(2004-2006) in Fragile and conflict affected situations in 1978 to that in 1981?
Offer a terse response. 0.89. What is the ratio of the Production index(2004-2006) in Mexico in 1978 to that in 1981?
Provide a short and direct response. 0.89. What is the ratio of the Production index(2004-2006) of Somalia in 1978 to that in 1981?
Your response must be concise. 0.91. What is the ratio of the Production index(2004-2006) of Fragile and conflict affected situations in 1978 to that in 1982?
Provide a succinct answer. 0.87. What is the ratio of the Production index(2004-2006) of Bulgaria in 1978 to that in 1982?
Provide a short and direct response. 0.87. What is the ratio of the Production index(2004-2006) of Mexico in 1978 to that in 1982?
Give a very brief answer. 0.89. What is the ratio of the Production index(2004-2006) in Somalia in 1978 to that in 1982?
Provide a short and direct response. 0.88. What is the ratio of the Production index(2004-2006) of Fragile and conflict affected situations in 1978 to that in 1983?
Offer a very short reply. 0.88. What is the ratio of the Production index(2004-2006) in Bulgaria in 1978 to that in 1983?
Give a very brief answer. 0.96. What is the ratio of the Production index(2004-2006) of Mexico in 1978 to that in 1983?
Offer a very short reply. 0.86. What is the ratio of the Production index(2004-2006) in Somalia in 1978 to that in 1983?
Provide a short and direct response. 0.91. What is the ratio of the Production index(2004-2006) in Fragile and conflict affected situations in 1978 to that in 1984?
Keep it short and to the point. 0.88. What is the ratio of the Production index(2004-2006) of Bulgaria in 1978 to that in 1984?
Offer a very short reply. 0.88. What is the ratio of the Production index(2004-2006) in Mexico in 1978 to that in 1984?
Your response must be concise. 0.86. What is the ratio of the Production index(2004-2006) of Somalia in 1978 to that in 1984?
Make the answer very short. 0.92. What is the ratio of the Production index(2004-2006) in Fragile and conflict affected situations in 1979 to that in 1980?
Keep it short and to the point. 0.93. What is the ratio of the Production index(2004-2006) in Bulgaria in 1979 to that in 1980?
Provide a short and direct response. 1.03. What is the ratio of the Production index(2004-2006) in Somalia in 1979 to that in 1980?
Offer a terse response. 0.96. What is the ratio of the Production index(2004-2006) in Fragile and conflict affected situations in 1979 to that in 1981?
Your response must be concise. 0.89. What is the ratio of the Production index(2004-2006) in Bulgaria in 1979 to that in 1981?
Your answer should be compact. 0.95. What is the ratio of the Production index(2004-2006) in Mexico in 1979 to that in 1981?
Provide a short and direct response. 0.87. What is the ratio of the Production index(2004-2006) of Somalia in 1979 to that in 1981?
Make the answer very short. 0.93. What is the ratio of the Production index(2004-2006) in Fragile and conflict affected situations in 1979 to that in 1982?
Your answer should be very brief. 0.87. What is the ratio of the Production index(2004-2006) of Bulgaria in 1979 to that in 1982?
Provide a short and direct response. 0.91. What is the ratio of the Production index(2004-2006) in Mexico in 1979 to that in 1982?
Give a very brief answer. 0.86. What is the ratio of the Production index(2004-2006) in Somalia in 1979 to that in 1982?
Give a very brief answer. 0.89. What is the ratio of the Production index(2004-2006) in Fragile and conflict affected situations in 1979 to that in 1983?
Your answer should be compact. 0.87. What is the ratio of the Production index(2004-2006) of Mexico in 1979 to that in 1983?
Give a very brief answer. 0.83. What is the ratio of the Production index(2004-2006) of Somalia in 1979 to that in 1983?
Give a very brief answer. 0.93. What is the ratio of the Production index(2004-2006) in Fragile and conflict affected situations in 1979 to that in 1984?
Ensure brevity in your answer.  0.87. What is the ratio of the Production index(2004-2006) of Mexico in 1979 to that in 1984?
Offer a terse response. 0.83. What is the ratio of the Production index(2004-2006) of Somalia in 1979 to that in 1984?
Offer a very short reply. 0.93. What is the ratio of the Production index(2004-2006) of Fragile and conflict affected situations in 1980 to that in 1981?
Make the answer very short. 0.96. What is the ratio of the Production index(2004-2006) in Bulgaria in 1980 to that in 1981?
Keep it short and to the point. 0.93. What is the ratio of the Production index(2004-2006) of Mexico in 1980 to that in 1981?
Offer a terse response. 0.94. What is the ratio of the Production index(2004-2006) of Somalia in 1980 to that in 1981?
Provide a short and direct response. 0.97. What is the ratio of the Production index(2004-2006) of Fragile and conflict affected situations in 1980 to that in 1982?
Offer a very short reply. 0.94. What is the ratio of the Production index(2004-2006) in Bulgaria in 1980 to that in 1982?
Your answer should be very brief. 0.88. What is the ratio of the Production index(2004-2006) of Mexico in 1980 to that in 1982?
Your answer should be very brief. 0.93. What is the ratio of the Production index(2004-2006) in Somalia in 1980 to that in 1982?
Make the answer very short. 0.93. What is the ratio of the Production index(2004-2006) in Fragile and conflict affected situations in 1980 to that in 1983?
Offer a very short reply. 0.94. What is the ratio of the Production index(2004-2006) of Bulgaria in 1980 to that in 1983?
Provide a succinct answer. 0.97. What is the ratio of the Production index(2004-2006) of Mexico in 1980 to that in 1983?
Make the answer very short. 0.9. What is the ratio of the Production index(2004-2006) of Somalia in 1980 to that in 1983?
Your response must be concise. 0.97. What is the ratio of the Production index(2004-2006) of Fragile and conflict affected situations in 1980 to that in 1984?
Ensure brevity in your answer.  0.94. What is the ratio of the Production index(2004-2006) in Bulgaria in 1980 to that in 1984?
Make the answer very short. 0.89. What is the ratio of the Production index(2004-2006) in Mexico in 1980 to that in 1984?
Offer a terse response. 0.9. What is the ratio of the Production index(2004-2006) in Somalia in 1980 to that in 1984?
Your response must be concise. 0.97. What is the ratio of the Production index(2004-2006) in Fragile and conflict affected situations in 1981 to that in 1982?
Ensure brevity in your answer.  0.98. What is the ratio of the Production index(2004-2006) in Bulgaria in 1981 to that in 1982?
Your answer should be compact. 0.95. What is the ratio of the Production index(2004-2006) in Mexico in 1981 to that in 1982?
Offer a very short reply. 0.99. What is the ratio of the Production index(2004-2006) in Somalia in 1981 to that in 1982?
Provide a short and direct response. 0.96. What is the ratio of the Production index(2004-2006) of Bulgaria in 1981 to that in 1983?
Give a very brief answer. 1.04. What is the ratio of the Production index(2004-2006) of Mexico in 1981 to that in 1983?
Keep it short and to the point. 0.96. What is the ratio of the Production index(2004-2006) in Fragile and conflict affected situations in 1981 to that in 1984?
Provide a succinct answer. 0.98. What is the ratio of the Production index(2004-2006) of Bulgaria in 1981 to that in 1984?
Offer a very short reply. 0.96. What is the ratio of the Production index(2004-2006) in Mexico in 1981 to that in 1984?
Your answer should be compact. 0.96. What is the ratio of the Production index(2004-2006) in Somalia in 1981 to that in 1984?
Your answer should be very brief. 1.01. What is the ratio of the Production index(2004-2006) in Fragile and conflict affected situations in 1982 to that in 1983?
Your answer should be very brief. 1.01. What is the ratio of the Production index(2004-2006) in Bulgaria in 1982 to that in 1983?
Make the answer very short. 1.1. What is the ratio of the Production index(2004-2006) in Somalia in 1982 to that in 1983?
Your answer should be very brief. 1.04. What is the ratio of the Production index(2004-2006) of Fragile and conflict affected situations in 1982 to that in 1984?
Make the answer very short. 1. What is the ratio of the Production index(2004-2006) of Bulgaria in 1982 to that in 1984?
Keep it short and to the point. 1.01. What is the ratio of the Production index(2004-2006) in Mexico in 1982 to that in 1984?
Keep it short and to the point. 0.97. What is the ratio of the Production index(2004-2006) of Somalia in 1982 to that in 1984?
Offer a very short reply. 1.05. What is the ratio of the Production index(2004-2006) of Bulgaria in 1983 to that in 1984?
Your answer should be compact. 0.92. What is the ratio of the Production index(2004-2006) of Somalia in 1983 to that in 1984?
Provide a succinct answer. 1.01. What is the difference between the highest and the second highest Production index(2004-2006) in Fragile and conflict affected situations?
Offer a very short reply. 0.15. What is the difference between the highest and the second highest Production index(2004-2006) of Bulgaria?
Ensure brevity in your answer.  2.03. What is the difference between the highest and the second highest Production index(2004-2006) in Somalia?
Ensure brevity in your answer.  3.36. What is the difference between the highest and the lowest Production index(2004-2006) of Fragile and conflict affected situations?
Your answer should be very brief. 7.58. What is the difference between the highest and the lowest Production index(2004-2006) in Bulgaria?
Your response must be concise. 24.86. What is the difference between the highest and the lowest Production index(2004-2006) of Mexico?
Offer a terse response. 10.14. What is the difference between the highest and the lowest Production index(2004-2006) of Somalia?
Make the answer very short. 10.8. 